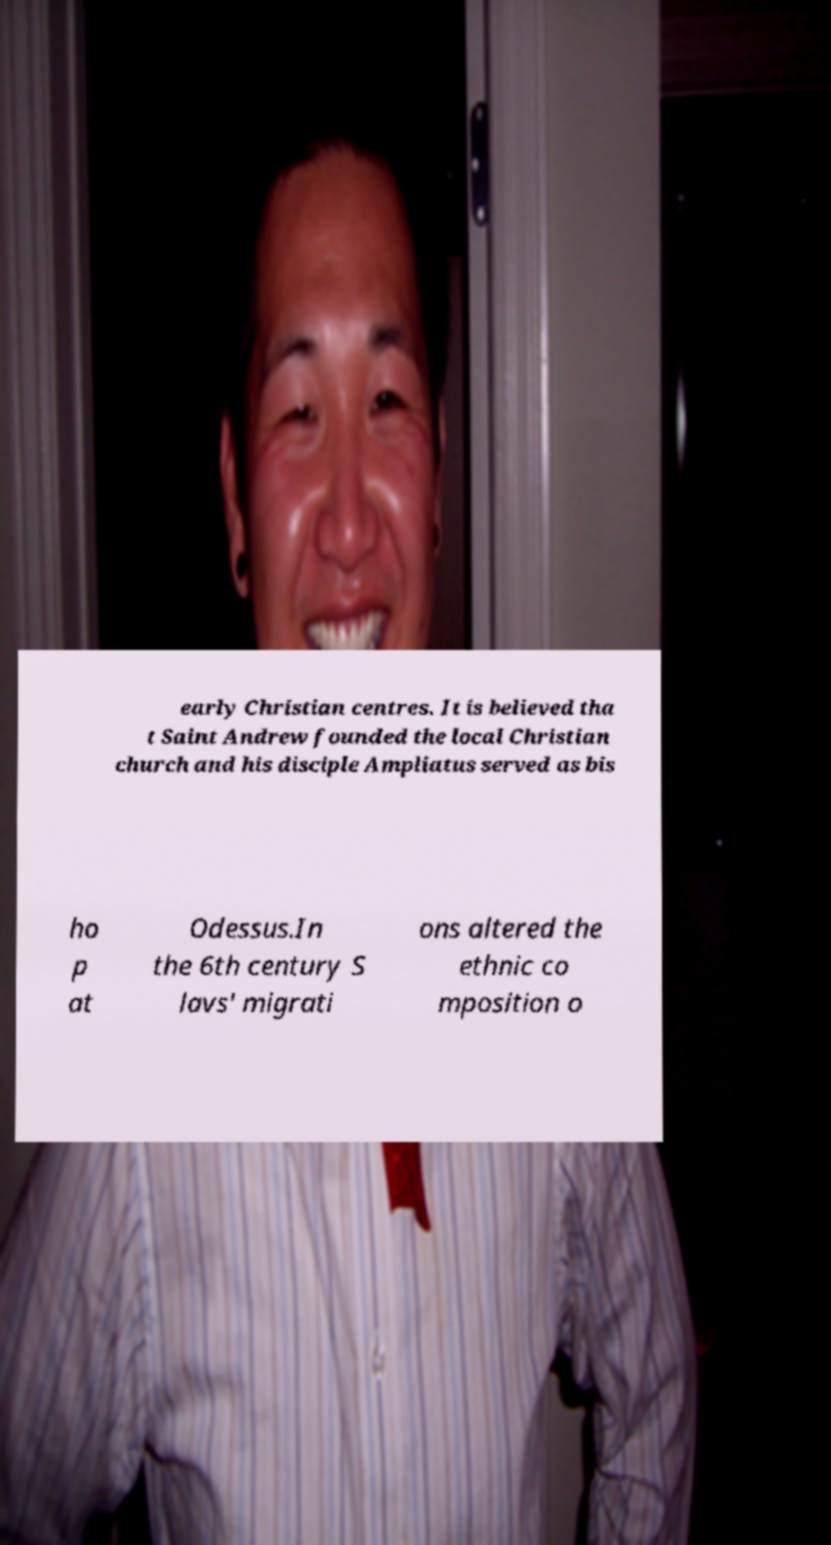Could you assist in decoding the text presented in this image and type it out clearly? early Christian centres. It is believed tha t Saint Andrew founded the local Christian church and his disciple Ampliatus served as bis ho p at Odessus.In the 6th century S lavs' migrati ons altered the ethnic co mposition o 